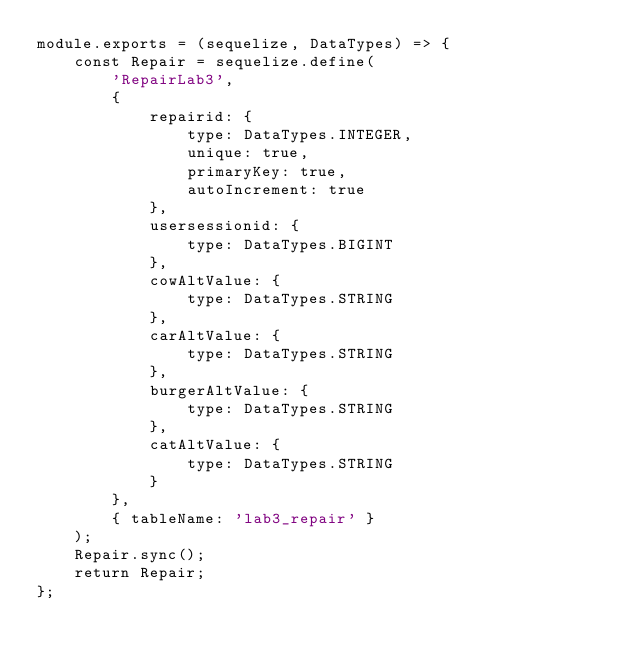<code> <loc_0><loc_0><loc_500><loc_500><_JavaScript_>module.exports = (sequelize, DataTypes) => {
	const Repair = sequelize.define(
		'RepairLab3',
		{
			repairid: {
				type: DataTypes.INTEGER,
				unique: true,
				primaryKey: true,
				autoIncrement: true
			},
			usersessionid: {
				type: DataTypes.BIGINT
			},
			cowAltValue: {
				type: DataTypes.STRING
			},
			carAltValue: {
				type: DataTypes.STRING
			},
			burgerAltValue: {
				type: DataTypes.STRING
			},
			catAltValue: {
				type: DataTypes.STRING
			}
		},
		{ tableName: 'lab3_repair' }
	);
	Repair.sync();
	return Repair;
};
</code> 